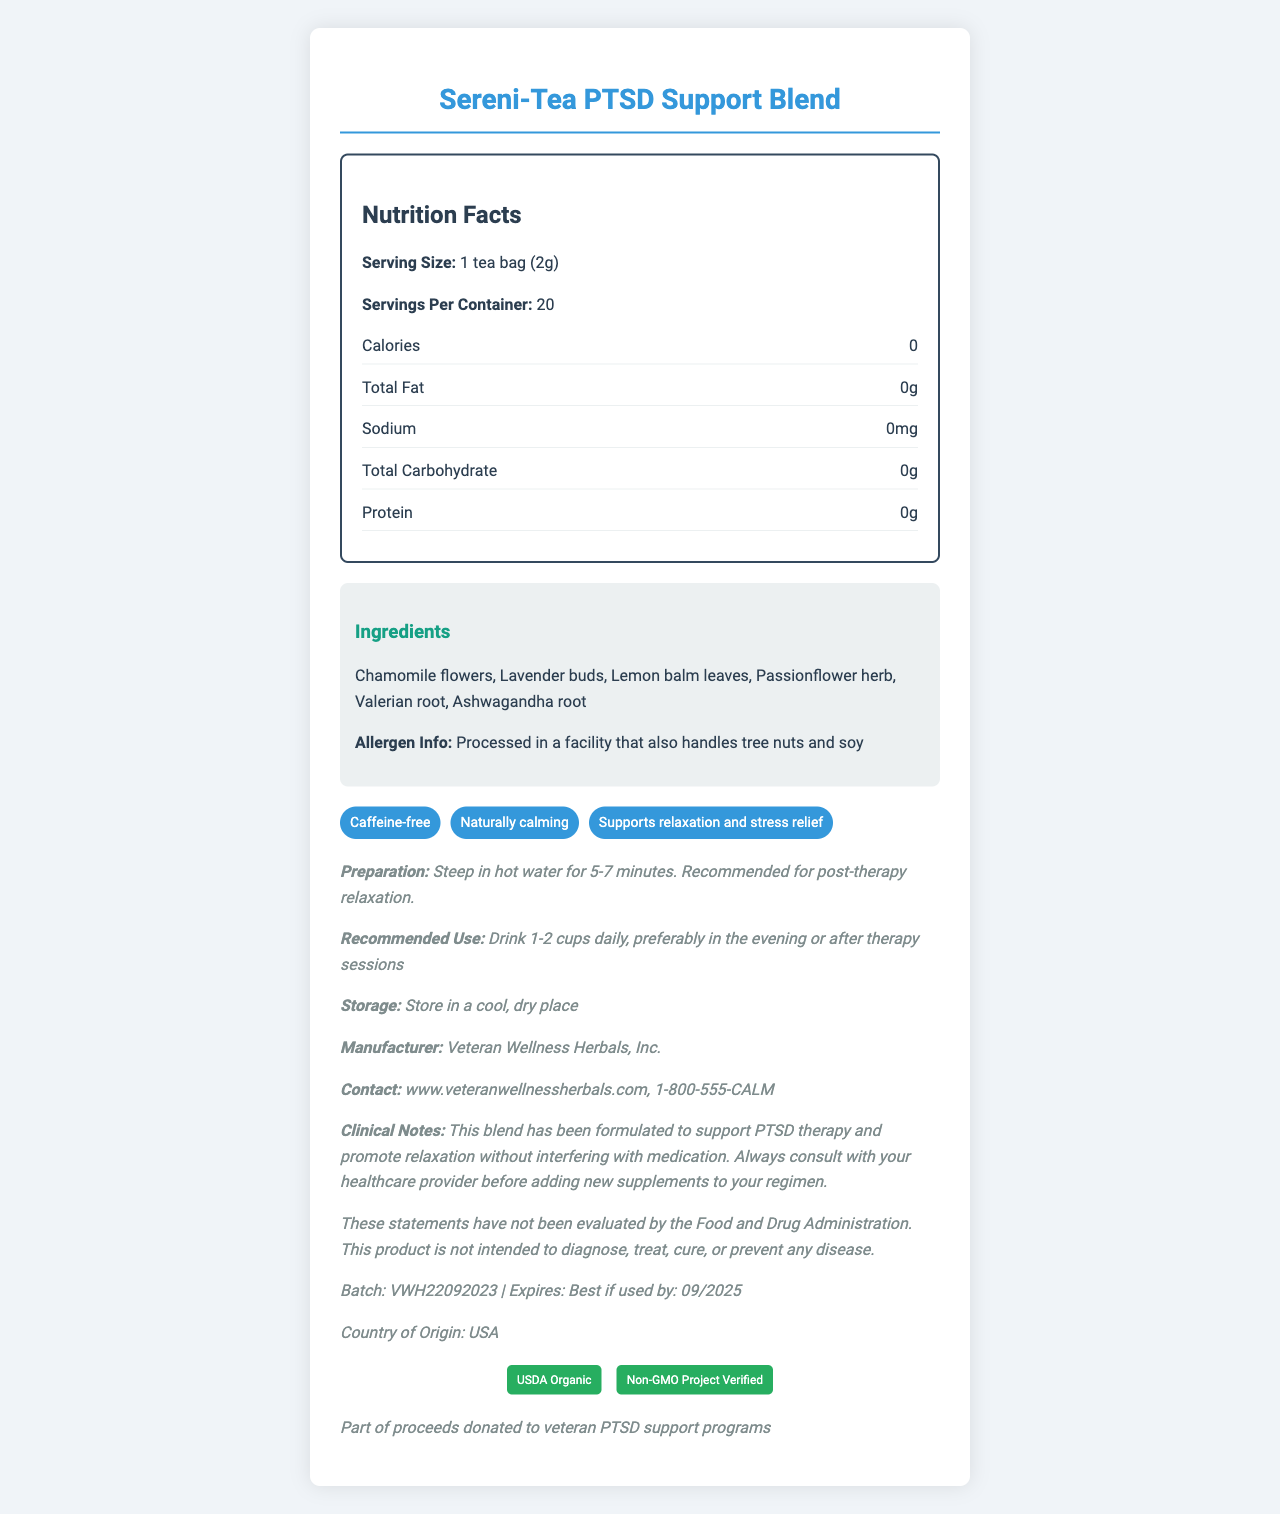what is the serving size? The serving size is explicitly stated near the top of the Nutrition Facts section.
Answer: 1 tea bag (2g) How many calories are in one serving? This information is listed in the Nutrition Facts under the section for Calories.
Answer: 0 calories What are the recommended storage instructions? This is mentioned near the bottom of the document under the additional info.
Answer: Store in a cool, dry place List two main health claims of the Sereni-Tea PTSD Support Blend. There are three health claims provided in the document, and two of them are "Caffeine-free" and "Naturally calming".
Answer: Caffeine-free, Naturally calming What is the expiration date of this product? This information is found at the bottom section of the document under "Batch" information.
Answer: Best if used by: 09/2025 which ingredient is NOT in the Sereni-Tea PTSD Support Blend? A. Chamomile flowers B. Ashwagandha root C. Green Tea D. Lavender buds The ingredients list does not include Green Tea; it includes Chamomile flowers, Ashwagandha root, and Lavender buds among others.
Answer: C. Green Tea What certifications does this product have? A. USDA Organic B. Non-GMO Project Verified C. Fair Trade D. Both A and B The document mentions that the product is USDA Organic and Non-GMO Project Verified, implying both certifications are held.
Answer: D. Both A and B Does the Sereni-Tea blend contain caffeine? The product is explicitly labeled as "Caffeine-free".
Answer: No Summarize the purpose and key details of the Sereni-Tea PTSD Support Blend. The summary covers the product's purpose, key ingredients, recommendations for use, and certifications, providing a comprehensive overview.
Answer: The Sereni-Tea PTSD Support Blend is a caffeine-free herbal tea designed to support PTSD therapy and promote relaxation. It contains various calming ingredients, including Chamomile and Valerian root. It is USDA Organic and Non-GMO Project Verified, and can be used daily, especially in the evening or after therapy sessions. The product is manufactured by Veteran Wellness Herbals, Inc. Can you drink more than one cup of Sereni-Tea daily? The recommended use section advises drinking 1-2 cups daily.
Answer: Yes Is this product manufactured in the USA? The document states that the country of origin is the USA.
Answer: Yes What are the preparation instructions for this tea blend? This instruction is directly under the preparation section.
Answer: Steep in hot water for 5-7 minutes. Recommended for post-therapy relaxation. Can this tea be used to diagnose a disease? The document includes a disclaimer stating the product is not intended to diagnose, treat, cure, or prevent any disease.
Answer: No What is the primary purpose of this document? This explanation covers the main areas of focus within the nutrition facts label and additional product details.
Answer: To provide nutrition and product information for the Sereni-Tea PTSD Support Blend, including ingredients, health claims, preparation instructions, and manufacturer details. What is the complete allergen information for the Sereni-Tea? This detailed allergen information is listed under the ingredients section.
Answer: Processed in a facility that also handles tree nuts and soy How does this product support veterans? This charitable aspect is mentioned in the additional info section at the end of the document.
Answer: Part of proceeds donated to veteran PTSD support programs What medication interactions should you be cautious of with this tea? The document suggests consulting with a healthcare provider before adding new supplements, but it does not mention specific medication interactions.
Answer: Cannot be determined 